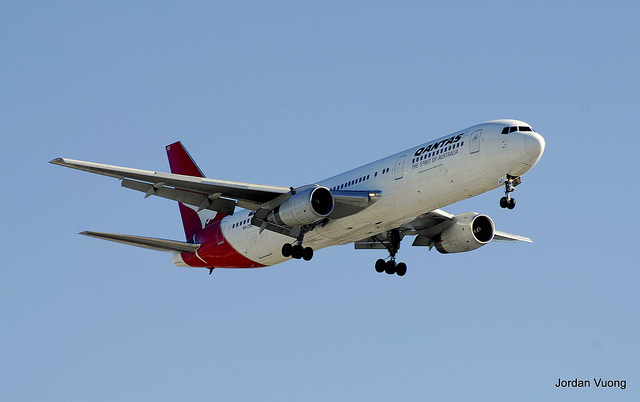Please transcribe the text in this image. QANTAS Vuong Jordan 